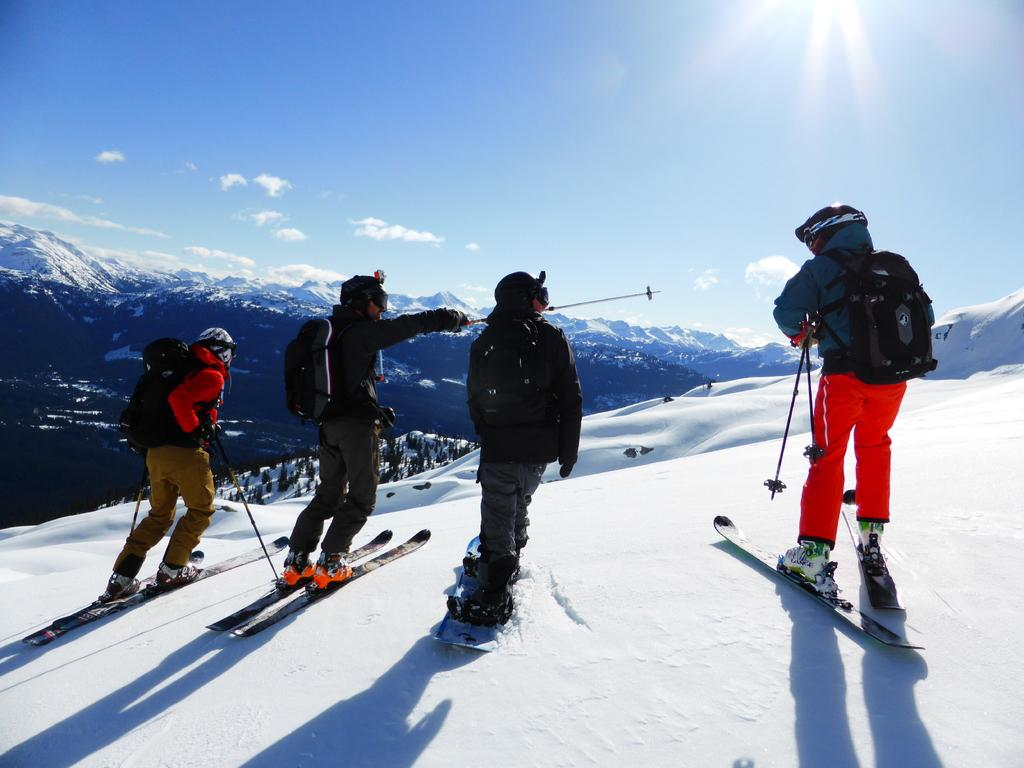How many people are in the image? There are four people in the image. What are the people doing in the image? The people are standing on ski boards. What can be seen in the background of the image? There are mountains and trees in the background of the image. What is visible at the top of the image? The sky is visible at the top of the image. What is present at the bottom of the image? There is ice at the bottom of the image. Can you see any berries growing on the trees in the image? There is no mention of berries or trees with berries in the image. How does the mind of the person on the left ski board affect their performance in the image? The image does not provide any information about the thoughts or mental state of the people in the image, so it is impossible to determine how their minds might affect their performance. 